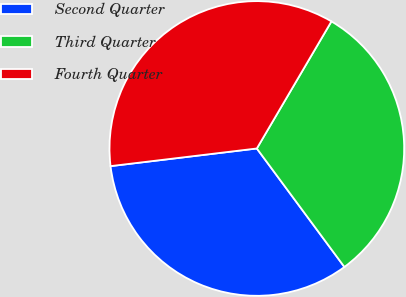<chart> <loc_0><loc_0><loc_500><loc_500><pie_chart><fcel>Second Quarter<fcel>Third Quarter<fcel>Fourth Quarter<nl><fcel>33.22%<fcel>31.42%<fcel>35.36%<nl></chart> 